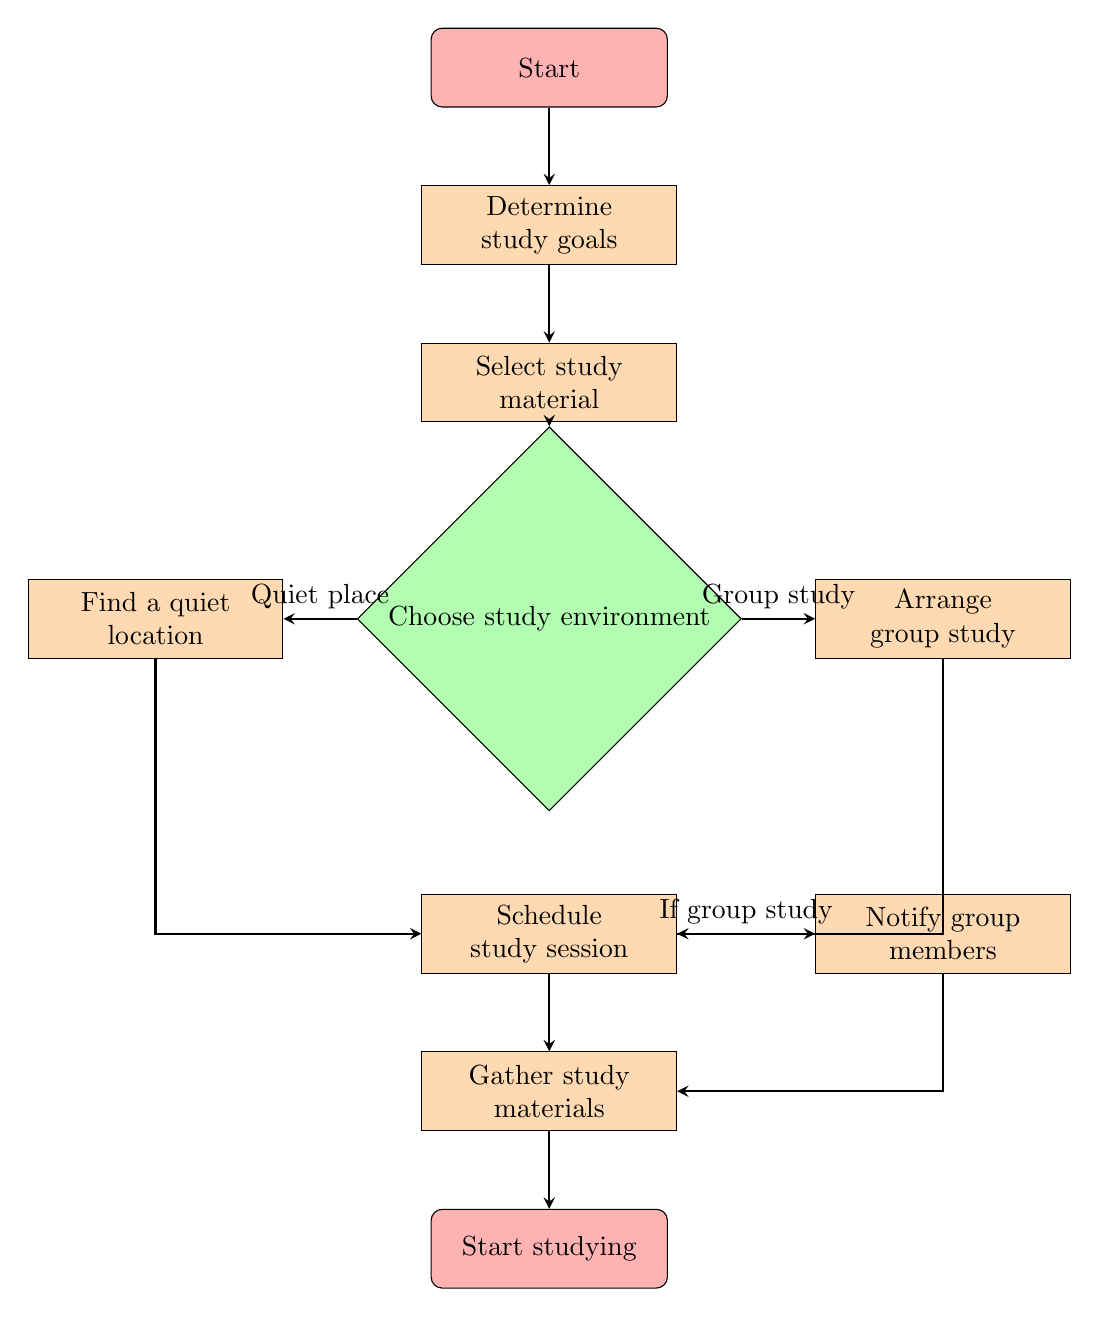What is the first step in the flow chart? The first step in the flow chart is labeled 'Start.' It is the initial node from which the process begins, guiding into the next steps.
Answer: Start How many decision nodes are in the chart? There is one decision node labeled 'Choose study environment.' This node presents a choice that affects the flow of the process, leading to different paths.
Answer: 1 What do you do after selecting study material? After selecting study material, the next step is 'Choose study environment.' This node indicates that the user must make a decision about where to study.
Answer: Choose study environment If the chosen study environment is 'Group study,' what is the next action? If 'Group study' is chosen, the flow continues to 'Arrange group study with peers.' This tells us that if a group study is selected, certain arrangements need to be made.
Answer: Arrange group study What comes after scheduling a study session? After scheduling a study session, the next step is 'Notify group members (if applicable).' This shows the necessity to inform others if group study is involved.
Answer: Notify group members What is the final outcome of the chart? The final outcome of the chart is labeled 'Start studying.' It symbolizes the conclusion of all preparatory steps and signifies the initiation of the actual study process.
Answer: Start studying What is the input to the decision node regarding study environment? The inputs to the decision node are 'Quiet place' and 'Group study.' These are the two paths that can be taken based on the user's preference.
Answer: Quiet place, Group study Which node follows 'Find a quiet location'? 'Schedule study session' follows 'Find a quiet location.' This shows that finding a study space leads directly to setting a time for the session.
Answer: Schedule study session If you choose a quiet place, which node is reached next? If a quiet place is chosen, it leads to the 'Schedule study session' node. This means that after finding a quiet location, one must schedule the actual study time.
Answer: Schedule study session 